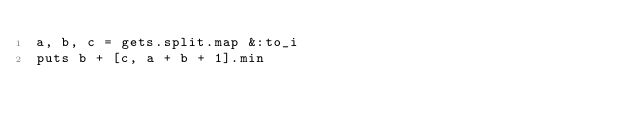<code> <loc_0><loc_0><loc_500><loc_500><_Ruby_>a, b, c = gets.split.map &:to_i
puts b + [c, a + b + 1].min</code> 